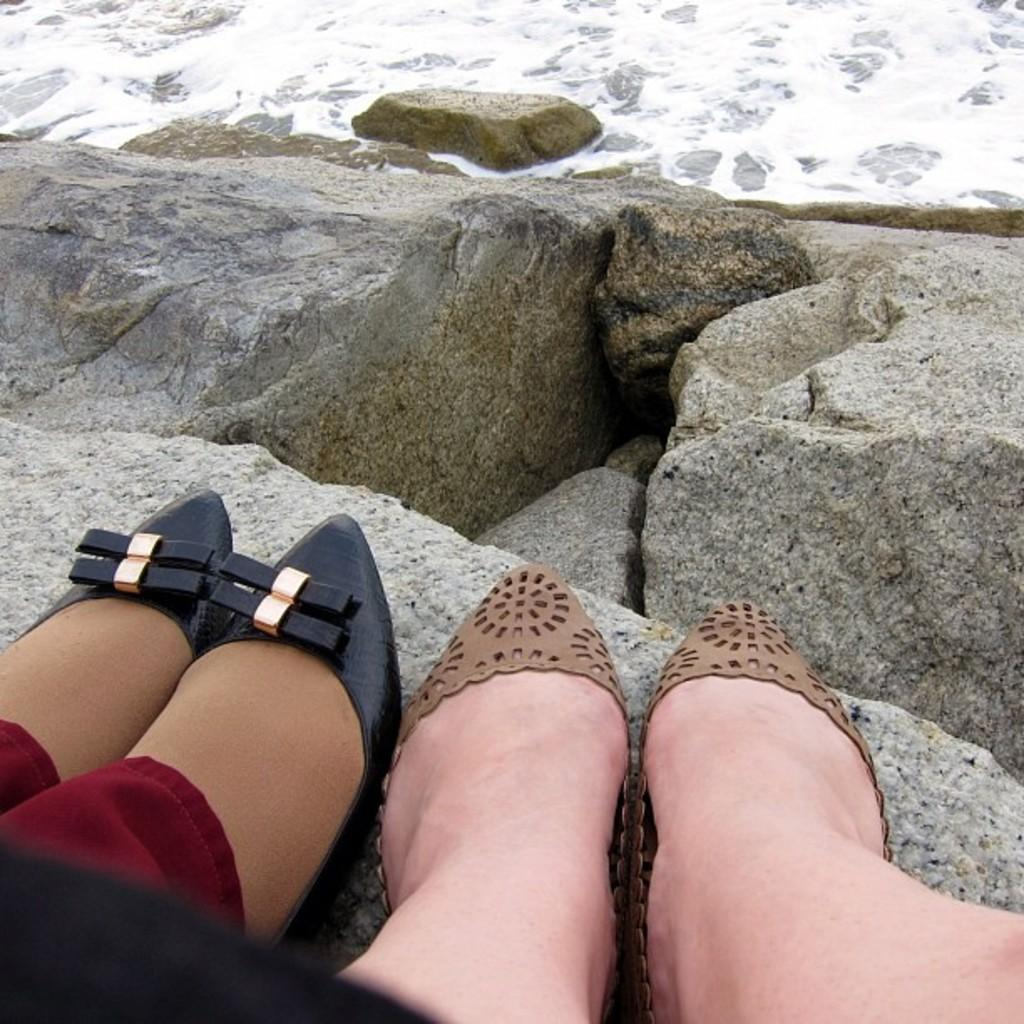What can be seen in the image that belongs to people? There are legs of people visible in the image. What type of natural elements are present in the image? There are stones and water visible in the image. What committee is meeting in the image? There is no committee meeting in the image; it only shows legs of people, stones, and water. 